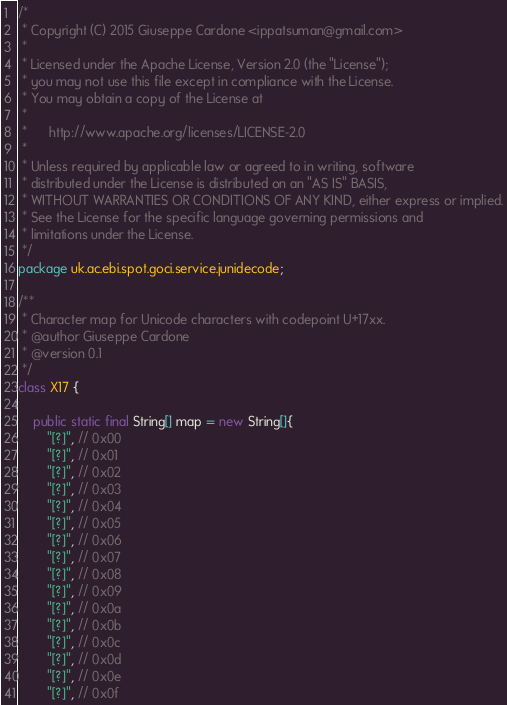<code> <loc_0><loc_0><loc_500><loc_500><_Java_>/*
 * Copyright (C) 2015 Giuseppe Cardone <ippatsuman@gmail.com>
 *
 * Licensed under the Apache License, Version 2.0 (the "License");
 * you may not use this file except in compliance with the License.
 * You may obtain a copy of the License at
 *
 *      http://www.apache.org/licenses/LICENSE-2.0
 *
 * Unless required by applicable law or agreed to in writing, software
 * distributed under the License is distributed on an "AS IS" BASIS,
 * WITHOUT WARRANTIES OR CONDITIONS OF ANY KIND, either express or implied.
 * See the License for the specific language governing permissions and
 * limitations under the License.
 */
package uk.ac.ebi.spot.goci.service.junidecode;

/**
 * Character map for Unicode characters with codepoint U+17xx.
 * @author Giuseppe Cardone
 * @version 0.1
 */
class X17 {

    public static final String[] map = new String[]{
        "[?]", // 0x00
        "[?]", // 0x01
        "[?]", // 0x02
        "[?]", // 0x03
        "[?]", // 0x04
        "[?]", // 0x05
        "[?]", // 0x06
        "[?]", // 0x07
        "[?]", // 0x08
        "[?]", // 0x09
        "[?]", // 0x0a
        "[?]", // 0x0b
        "[?]", // 0x0c
        "[?]", // 0x0d
        "[?]", // 0x0e
        "[?]", // 0x0f</code> 